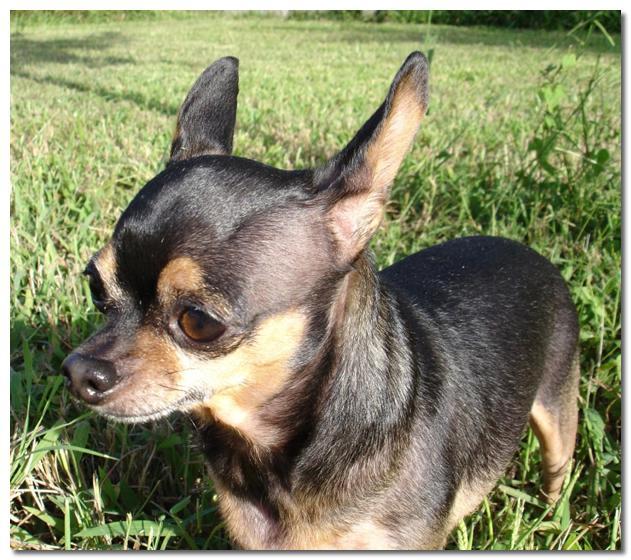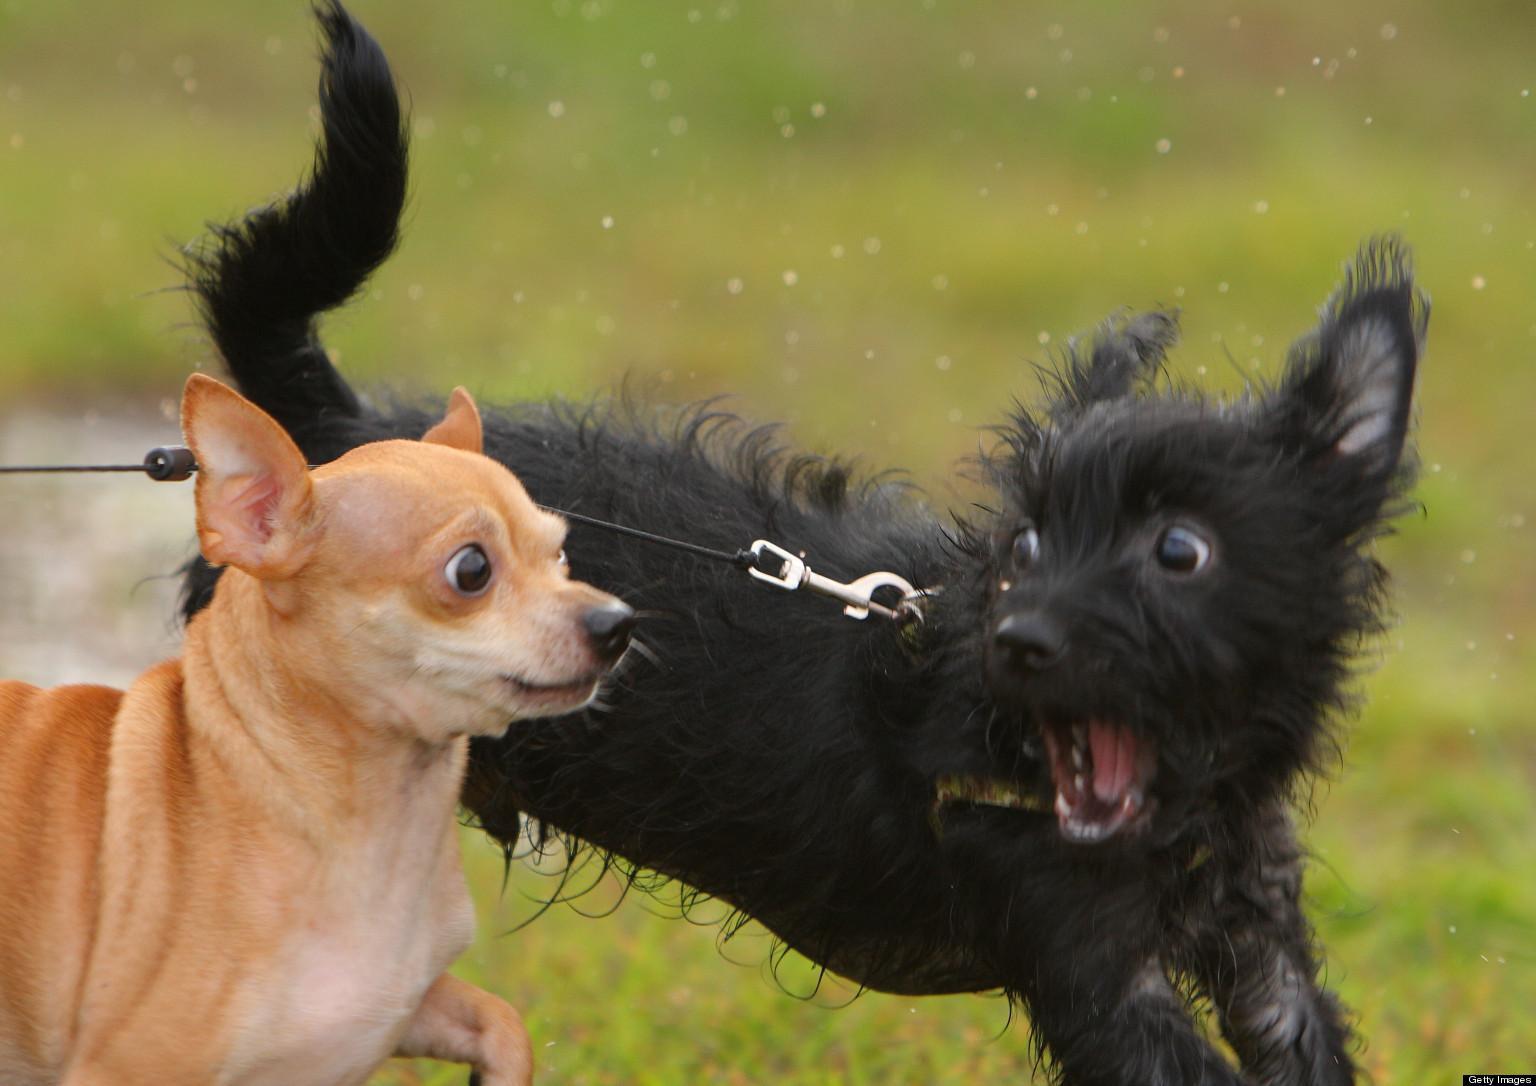The first image is the image on the left, the second image is the image on the right. Examine the images to the left and right. Is the description "All dogs in the images are running across the grass." accurate? Answer yes or no. No. The first image is the image on the left, the second image is the image on the right. Analyze the images presented: Is the assertion "there is a mostly black dog leaping through the air in the image on the left" valid? Answer yes or no. No. 